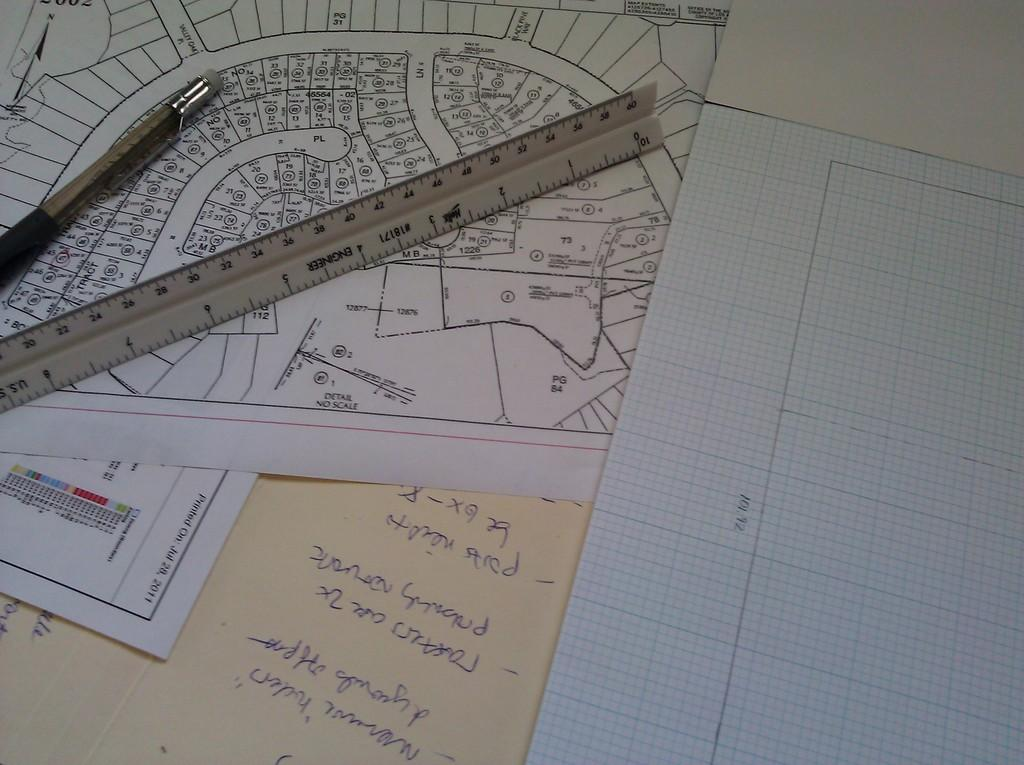Provide a one-sentence caption for the provided image. Scattered papers on a desk reveal the date of July 28, 2011 on one of them. 